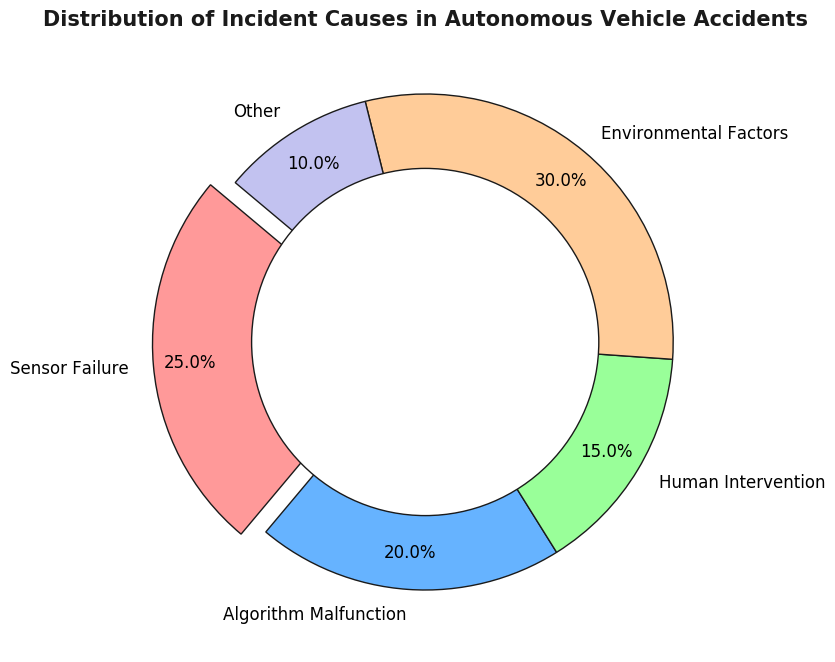what is the largest cause of incidents shown in the pie chart? The largest cause can be identified by looking at the segment with the largest percentage. In the pie chart, "Environmental Factors" takes up the most space, with 30%.
Answer: Environmental Factors Which cause has the second highest percentage of incidents? To find the second highest percentage, look for the second largest segment. "Sensor Failure" is the second largest, occupying 25%.
Answer: Sensor Failure What is the combined percentage of incidents caused by algorithm malfunction and other factors? Add the percentages of "Algorithm Malfunction" (20%) and "Other" (10%) together: 20% + 10% = 30%.
Answer: 30% Is the proportion of incidents caused by human intervention greater or lesser than the proportion caused by algorithm malfunction? Compare the segments labeled "Human Intervention" (15%) and "Algorithm Malfunction" (20%). 15% is less than 20%.
Answer: Lesser How much larger is the percentage of incidents attributed to environmental factors compared to human intervention? Subtract the percentage of "Human Intervention" (15%) from "Environmental Factors" (30%): 30% - 15% = 15%.
Answer: 15% Which segment is visually distinguished by being exploded from the rest of the pie chart? The only segment separated slightly from the pie chart (exploded) is "Sensor Failure," which can be identified by its visual distinction.
Answer: Sensor Failure If you remove the "Other" category, what percentage does the "Sensor Failure" category represent of the remaining causes? The total percentage excluding "Other" is 100% - 10% = 90%. "Sensor Failure" is 25% of 100%. To find its new proportion of the remaining causes: (25 / 90) * 100 ≈ 27.8%.
Answer: 27.8% Which color is used for the environmental factors segment in the chart? The segment for "Environmental Factors" can be recognized by its color which is orange in the chart.
Answer: Orange Do algorithm malfunction and sensor failure together make up more than half of the incidents? Add their percentages: "Algorithm Malfunction" (20%) + "Sensor Failure" (25%) = 45%. 45% is less than 50%.
Answer: No What is the smallest category in the pie chart, and what is its percentage? The smallest segment can be identified as "Other," which occupies the least space on the pie chart with a percentage of 10%.
Answer: Other, 10% 